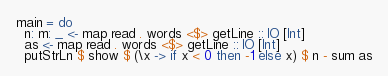Convert code to text. <code><loc_0><loc_0><loc_500><loc_500><_Haskell_>main = do
  n: m: _ <- map read . words <$> getLine :: IO [Int]
  as <- map read . words <$> getLine :: IO [Int]
  putStrLn $ show $ (\x -> if x < 0 then -1 else x) $ n - sum as
</code> 